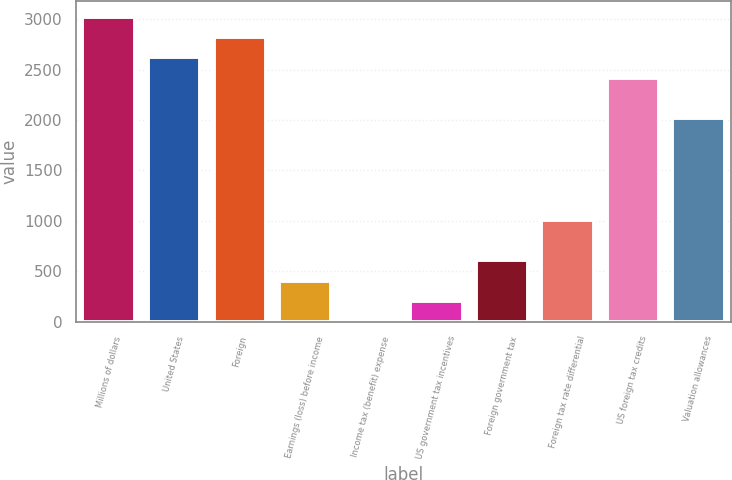Convert chart. <chart><loc_0><loc_0><loc_500><loc_500><bar_chart><fcel>Millions of dollars<fcel>United States<fcel>Foreign<fcel>Earnings (loss) before income<fcel>Income tax (benefit) expense<fcel>US government tax incentives<fcel>Foreign government tax<fcel>Foreign tax rate differential<fcel>US foreign tax credits<fcel>Valuation allowances<nl><fcel>3025<fcel>2622.2<fcel>2823.6<fcel>406.8<fcel>4<fcel>205.4<fcel>608.2<fcel>1011<fcel>2420.8<fcel>2018<nl></chart> 